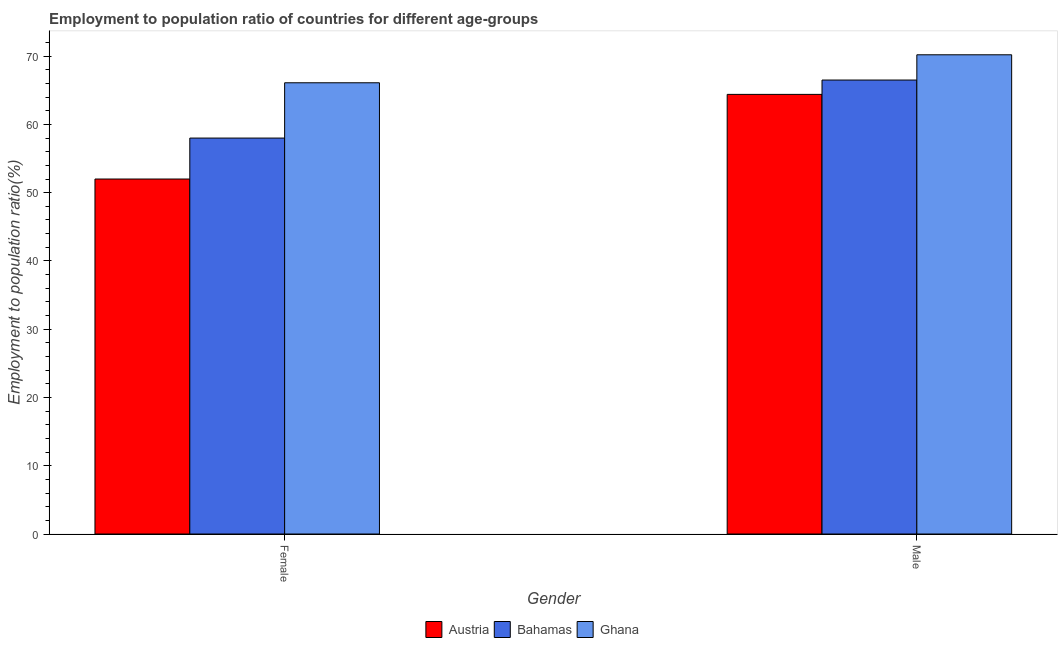How many groups of bars are there?
Your response must be concise. 2. What is the employment to population ratio(female) in Ghana?
Keep it short and to the point. 66.1. Across all countries, what is the maximum employment to population ratio(female)?
Offer a very short reply. 66.1. Across all countries, what is the minimum employment to population ratio(male)?
Your answer should be very brief. 64.4. In which country was the employment to population ratio(male) minimum?
Provide a succinct answer. Austria. What is the total employment to population ratio(female) in the graph?
Keep it short and to the point. 176.1. What is the difference between the employment to population ratio(female) in Austria and that in Bahamas?
Your answer should be very brief. -6. What is the difference between the employment to population ratio(female) in Ghana and the employment to population ratio(male) in Bahamas?
Your answer should be very brief. -0.4. What is the average employment to population ratio(male) per country?
Provide a short and direct response. 67.03. What is the difference between the employment to population ratio(male) and employment to population ratio(female) in Ghana?
Ensure brevity in your answer.  4.1. In how many countries, is the employment to population ratio(female) greater than 52 %?
Provide a short and direct response. 2. What is the ratio of the employment to population ratio(female) in Ghana to that in Austria?
Your answer should be very brief. 1.27. What does the 2nd bar from the right in Male represents?
Your answer should be very brief. Bahamas. Are all the bars in the graph horizontal?
Give a very brief answer. No. How many countries are there in the graph?
Your response must be concise. 3. Does the graph contain any zero values?
Your answer should be compact. No. Does the graph contain grids?
Provide a succinct answer. No. Where does the legend appear in the graph?
Provide a succinct answer. Bottom center. How are the legend labels stacked?
Give a very brief answer. Horizontal. What is the title of the graph?
Provide a short and direct response. Employment to population ratio of countries for different age-groups. Does "Palau" appear as one of the legend labels in the graph?
Make the answer very short. No. What is the label or title of the X-axis?
Provide a short and direct response. Gender. What is the label or title of the Y-axis?
Provide a short and direct response. Employment to population ratio(%). What is the Employment to population ratio(%) in Ghana in Female?
Make the answer very short. 66.1. What is the Employment to population ratio(%) of Austria in Male?
Keep it short and to the point. 64.4. What is the Employment to population ratio(%) of Bahamas in Male?
Make the answer very short. 66.5. What is the Employment to population ratio(%) of Ghana in Male?
Your answer should be very brief. 70.2. Across all Gender, what is the maximum Employment to population ratio(%) of Austria?
Your response must be concise. 64.4. Across all Gender, what is the maximum Employment to population ratio(%) of Bahamas?
Provide a short and direct response. 66.5. Across all Gender, what is the maximum Employment to population ratio(%) of Ghana?
Give a very brief answer. 70.2. Across all Gender, what is the minimum Employment to population ratio(%) of Ghana?
Offer a terse response. 66.1. What is the total Employment to population ratio(%) in Austria in the graph?
Ensure brevity in your answer.  116.4. What is the total Employment to population ratio(%) of Bahamas in the graph?
Offer a terse response. 124.5. What is the total Employment to population ratio(%) of Ghana in the graph?
Offer a very short reply. 136.3. What is the difference between the Employment to population ratio(%) in Austria in Female and that in Male?
Your answer should be compact. -12.4. What is the difference between the Employment to population ratio(%) in Ghana in Female and that in Male?
Ensure brevity in your answer.  -4.1. What is the difference between the Employment to population ratio(%) of Austria in Female and the Employment to population ratio(%) of Ghana in Male?
Your answer should be very brief. -18.2. What is the difference between the Employment to population ratio(%) of Bahamas in Female and the Employment to population ratio(%) of Ghana in Male?
Offer a very short reply. -12.2. What is the average Employment to population ratio(%) in Austria per Gender?
Your answer should be very brief. 58.2. What is the average Employment to population ratio(%) in Bahamas per Gender?
Keep it short and to the point. 62.25. What is the average Employment to population ratio(%) of Ghana per Gender?
Your answer should be very brief. 68.15. What is the difference between the Employment to population ratio(%) of Austria and Employment to population ratio(%) of Bahamas in Female?
Your response must be concise. -6. What is the difference between the Employment to population ratio(%) of Austria and Employment to population ratio(%) of Ghana in Female?
Provide a succinct answer. -14.1. What is the difference between the Employment to population ratio(%) of Bahamas and Employment to population ratio(%) of Ghana in Female?
Your answer should be very brief. -8.1. What is the difference between the Employment to population ratio(%) in Austria and Employment to population ratio(%) in Bahamas in Male?
Offer a very short reply. -2.1. What is the difference between the Employment to population ratio(%) in Bahamas and Employment to population ratio(%) in Ghana in Male?
Give a very brief answer. -3.7. What is the ratio of the Employment to population ratio(%) of Austria in Female to that in Male?
Make the answer very short. 0.81. What is the ratio of the Employment to population ratio(%) in Bahamas in Female to that in Male?
Your answer should be very brief. 0.87. What is the ratio of the Employment to population ratio(%) of Ghana in Female to that in Male?
Ensure brevity in your answer.  0.94. What is the difference between the highest and the second highest Employment to population ratio(%) of Austria?
Your answer should be very brief. 12.4. What is the difference between the highest and the lowest Employment to population ratio(%) in Austria?
Provide a succinct answer. 12.4. 